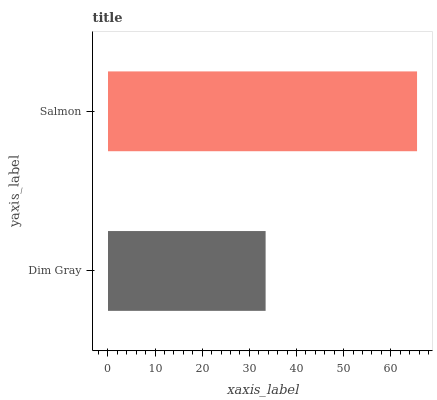Is Dim Gray the minimum?
Answer yes or no. Yes. Is Salmon the maximum?
Answer yes or no. Yes. Is Salmon the minimum?
Answer yes or no. No. Is Salmon greater than Dim Gray?
Answer yes or no. Yes. Is Dim Gray less than Salmon?
Answer yes or no. Yes. Is Dim Gray greater than Salmon?
Answer yes or no. No. Is Salmon less than Dim Gray?
Answer yes or no. No. Is Salmon the high median?
Answer yes or no. Yes. Is Dim Gray the low median?
Answer yes or no. Yes. Is Dim Gray the high median?
Answer yes or no. No. Is Salmon the low median?
Answer yes or no. No. 